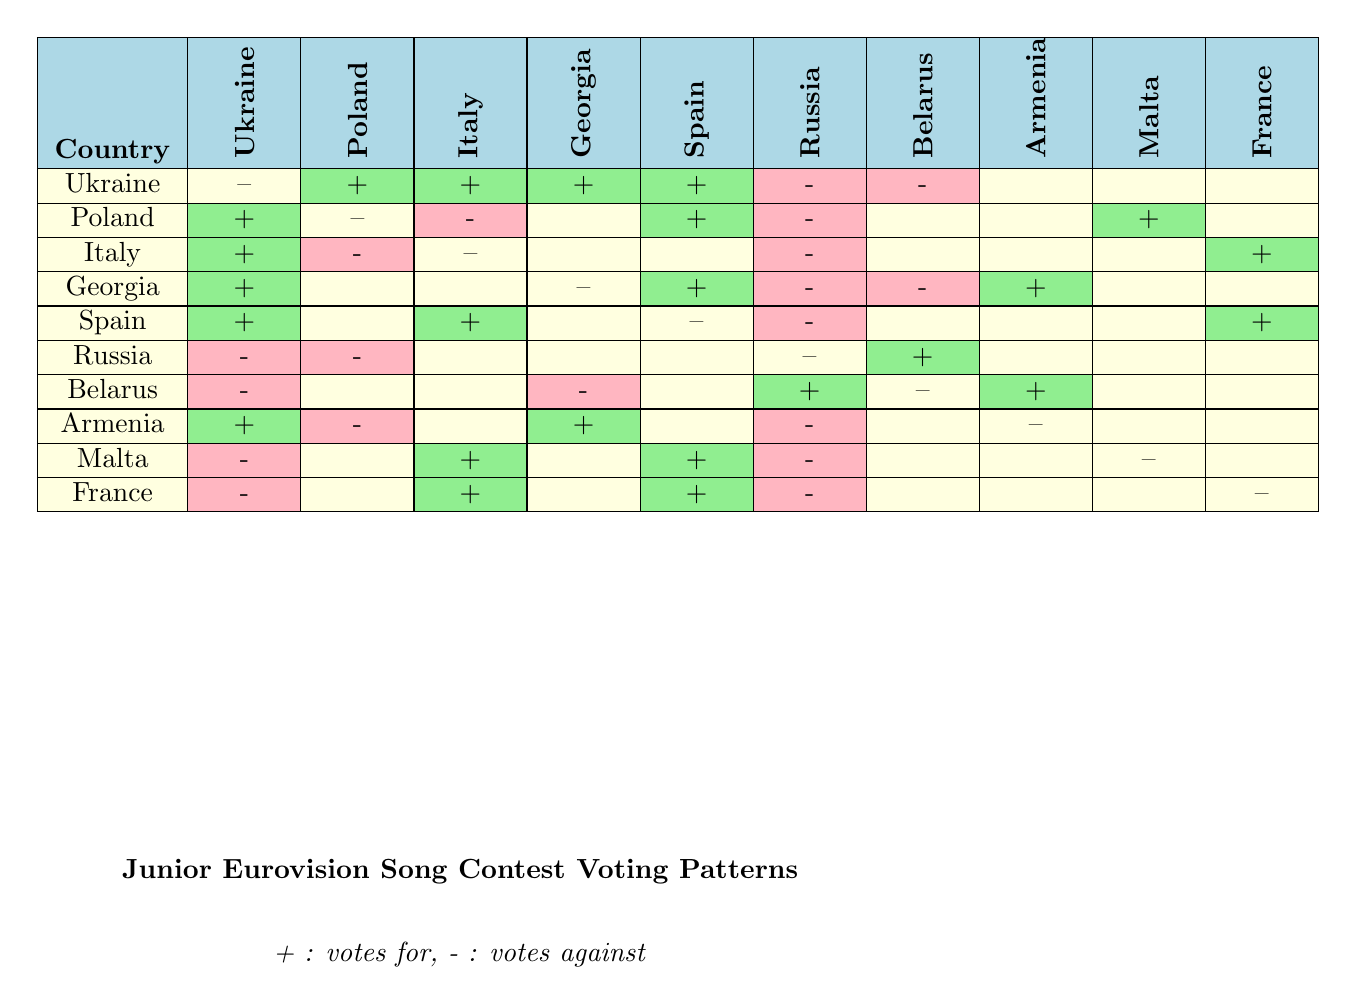What countries did Ukraine vote for? From the row corresponding to Ukraine in the table, the countries listed under "votes for" are Poland, Georgia, Italy, and Spain.
Answer: Poland, Georgia, Italy, Spain Which country received the most votes against? By examining the "votes against" sections for each country, Ukraine and Poland received votes against from Russia, while Belarus received votes against from both Ukraine and Georgia. Russia has two votes against (Ukraine and Poland), while others have one or none. Hence, Russia is the only country with two votes against.
Answer: Russia Did Georgia vote for Armenia? In the row for Georgia, there is no mention of Armenia under the "votes for" category. Thus, Georgia did not vote for Armenia.
Answer: No How many countries voted for Spain? Looking at the row corresponding to Spain, the countries listed under "votes for" are Ukraine, Italy, and France. So, a total of three countries voted for Spain.
Answer: Three Which countries received votes from both Ukraine and Georgia? By checking the "votes for" sections, both Ukraine and Georgia voted for themselves and also voted for Poland and Italy for Ukraine and Spain for Georgia. Therefore, the common country that both voted for is Ukraine (but Georgia voted for Ukraine and Ukraine for Georgia too).
Answer: Ukraine Which country had votes against from Russia and Belarus? By reviewing the votes against from both Russia and Belarus, we observe that Ukraine and Georgia received votes against from Russia, while Ukraine also received against votes from Belarus. Thus, the country that corresponds to this criterion is Ukraine.
Answer: Ukraine Did Armenia receive more votes against than votes for? Armenia's "votes for" included Georgia and Ukraine, which counts as two, while it had votes against from Poland and Russia, totalling two as well. Since they are equal, the answer is that Armenia does not have more votes against than votes for.
Answer: No What is the total number of votes against received by Malta? The row for Malta indicates it's against votes from Ukraine and Russia, totaling two. Thus, the answer is two.
Answer: Two 